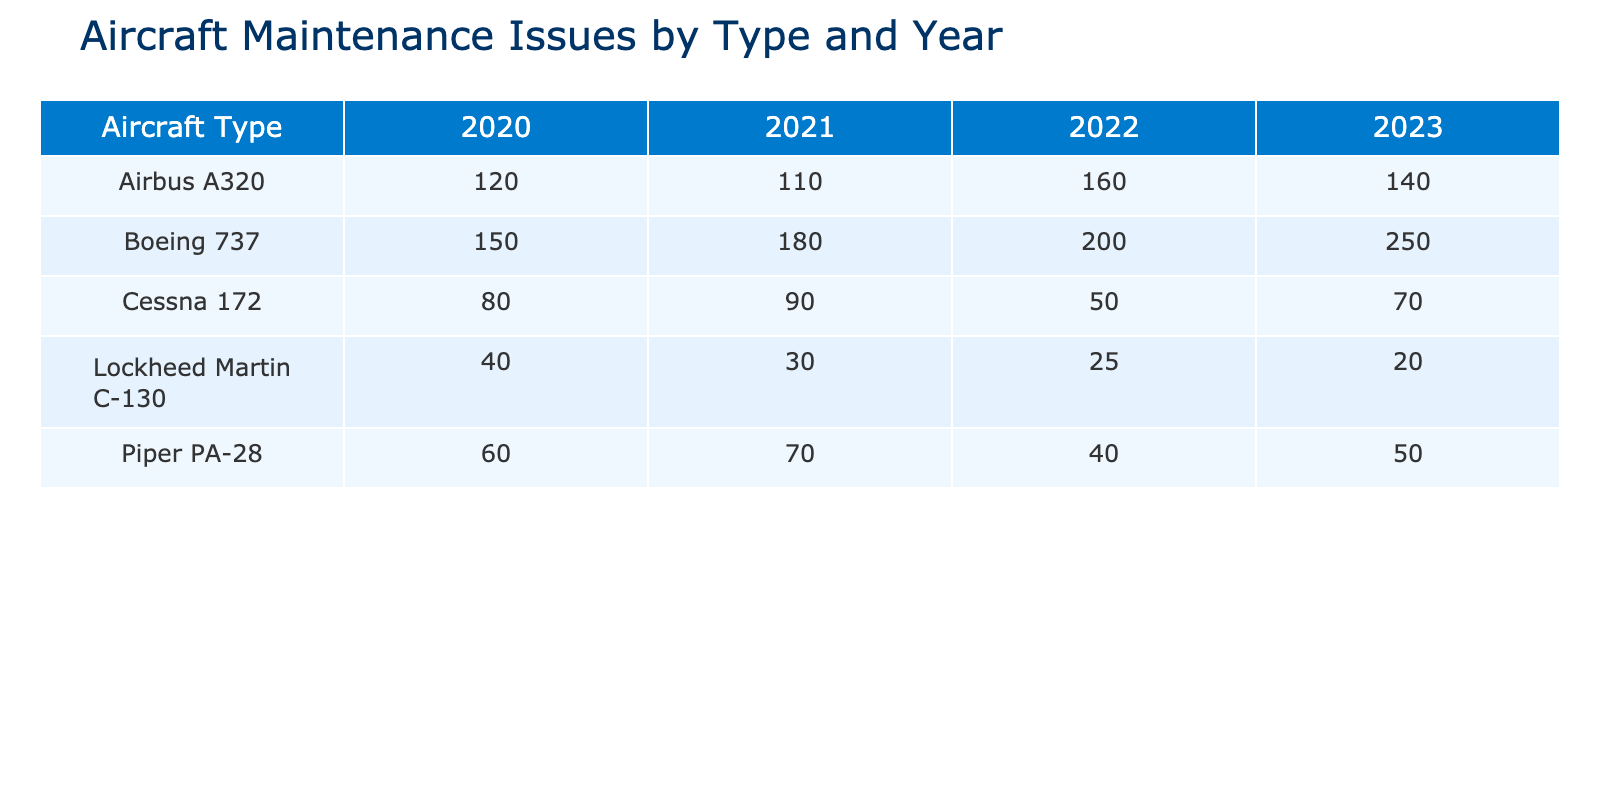What was the maintenance issue count for Boeing 737 in 2022? From the table, I find that the maintenance issue count for Boeing 737 in 2022 is listed under the 2022 column for Boeing 737, which is 200.
Answer: 200 How many maintenance issues were reported for Airbus A320 across all years combined? I will add the maintenance issue counts for Airbus A320 from each year: 120 (2020) + 110 (2021) + 160 (2022) + 140 (2023) = 630.
Answer: 630 Was there an increase in the maintenance issue count for Cessna 172 from 2021 to 2022? The count for Cessna 172 in 2021 was 90, while in 2022 it decreased to 50. Since 50 is less than 90, there was no increase.
Answer: No Which type of aircraft had the highest maintenance issues in 2023? I will inspect the 2023 column for all aircraft types. Boeing 737 has the highest count at 250, compared to the other types.
Answer: Boeing 737 Comparing all years, what is the total maintenance issue count for Lockheed Martin C-130? I will sum the counts: 40 (2020) + 30 (2021) + 25 (2022) + 20 (2023) = 115. So, the total maintenance issue count is 115.
Answer: 115 Was the number of maintenance issues for Piper PA-28 higher in 2021 or 2022? Piper PA-28 has 70 issues in 2021 and 40 in 2022. Since 70 is greater than 40, it had more issues in 2021.
Answer: 2021 What is the average maintenance issue count for Cessna 172 over the four years? The counts are 80 (2020), 90 (2021), 50 (2022), and 70 (2023). I will sum them: 80 + 90 + 50 + 70 = 290, and then divide by 4, giving an average of 72.5.
Answer: 72.5 Did the maintenance issue count for any aircraft type decrease from 2020 to 2023? I will compare each aircraft type's 2020 count with its 2023 count: Boeing 737 increased (150 to 250), Airbus A320 increased (120 to 140), Cessna 172 decreased (80 to 70), Piper PA-28 decreased (60 to 50), and Lockheed Martin C-130 decreased (40 to 20). Therefore, Cessna 172, Piper PA-28, and Lockheed Martin C-130 all decreased.
Answer: Yes, multiple types decreased 